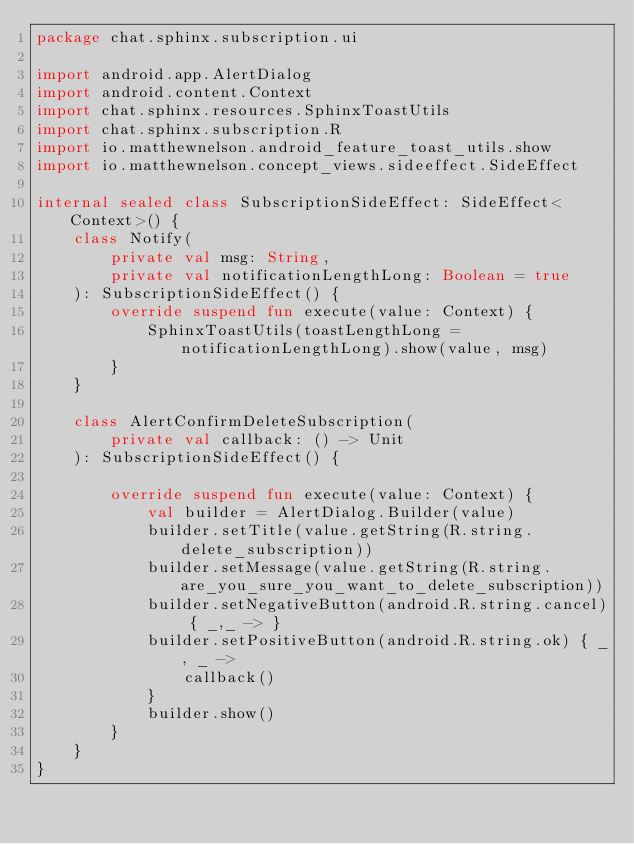Convert code to text. <code><loc_0><loc_0><loc_500><loc_500><_Kotlin_>package chat.sphinx.subscription.ui

import android.app.AlertDialog
import android.content.Context
import chat.sphinx.resources.SphinxToastUtils
import chat.sphinx.subscription.R
import io.matthewnelson.android_feature_toast_utils.show
import io.matthewnelson.concept_views.sideeffect.SideEffect

internal sealed class SubscriptionSideEffect: SideEffect<Context>() {
    class Notify(
        private val msg: String,
        private val notificationLengthLong: Boolean = true
    ): SubscriptionSideEffect() {
        override suspend fun execute(value: Context) {
            SphinxToastUtils(toastLengthLong = notificationLengthLong).show(value, msg)
        }
    }

    class AlertConfirmDeleteSubscription(
        private val callback: () -> Unit
    ): SubscriptionSideEffect() {

        override suspend fun execute(value: Context) {
            val builder = AlertDialog.Builder(value)
            builder.setTitle(value.getString(R.string.delete_subscription))
            builder.setMessage(value.getString(R.string.are_you_sure_you_want_to_delete_subscription))
            builder.setNegativeButton(android.R.string.cancel) { _,_ -> }
            builder.setPositiveButton(android.R.string.ok) { _, _ ->
                callback()
            }
            builder.show()
        }
    }
}
</code> 